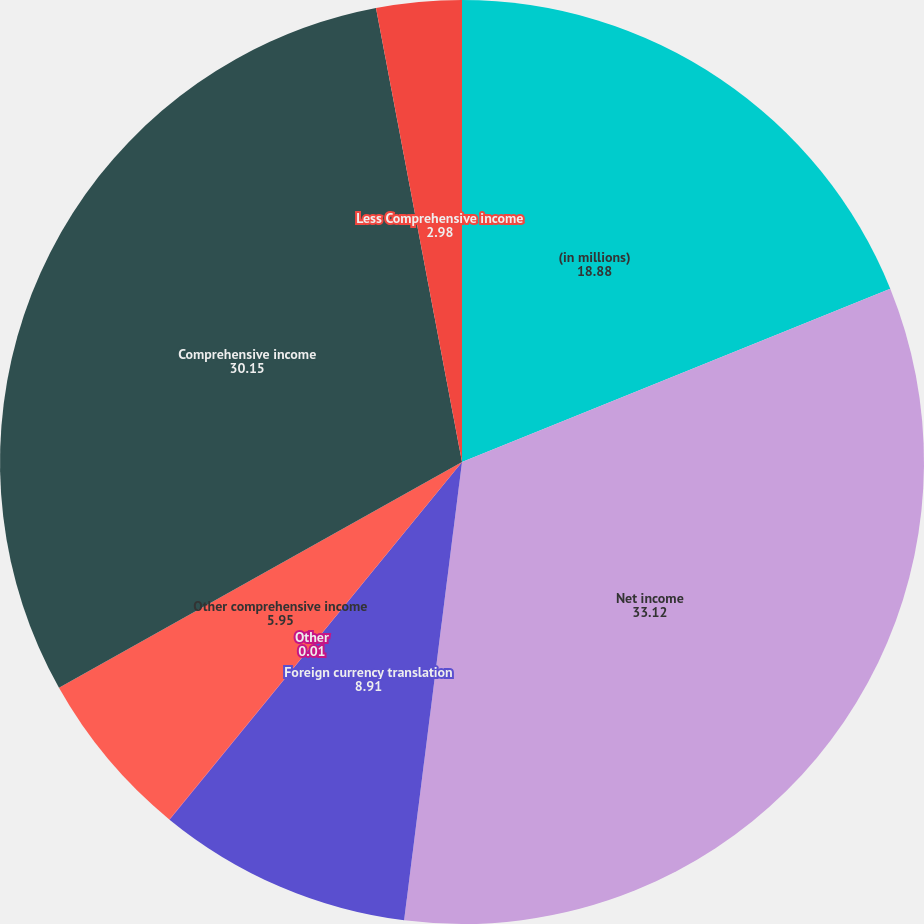Convert chart. <chart><loc_0><loc_0><loc_500><loc_500><pie_chart><fcel>(in millions)<fcel>Net income<fcel>Foreign currency translation<fcel>Other<fcel>Other comprehensive income<fcel>Comprehensive income<fcel>Less Comprehensive income<nl><fcel>18.88%<fcel>33.12%<fcel>8.91%<fcel>0.01%<fcel>5.95%<fcel>30.15%<fcel>2.98%<nl></chart> 